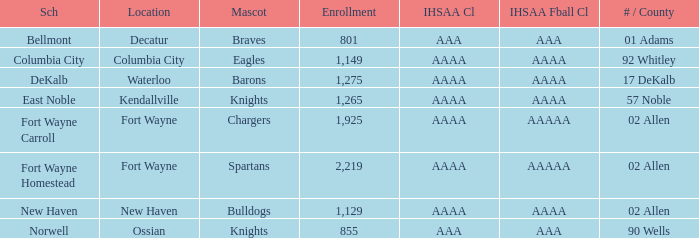What's the enrollment for Kendallville? 1265.0. 